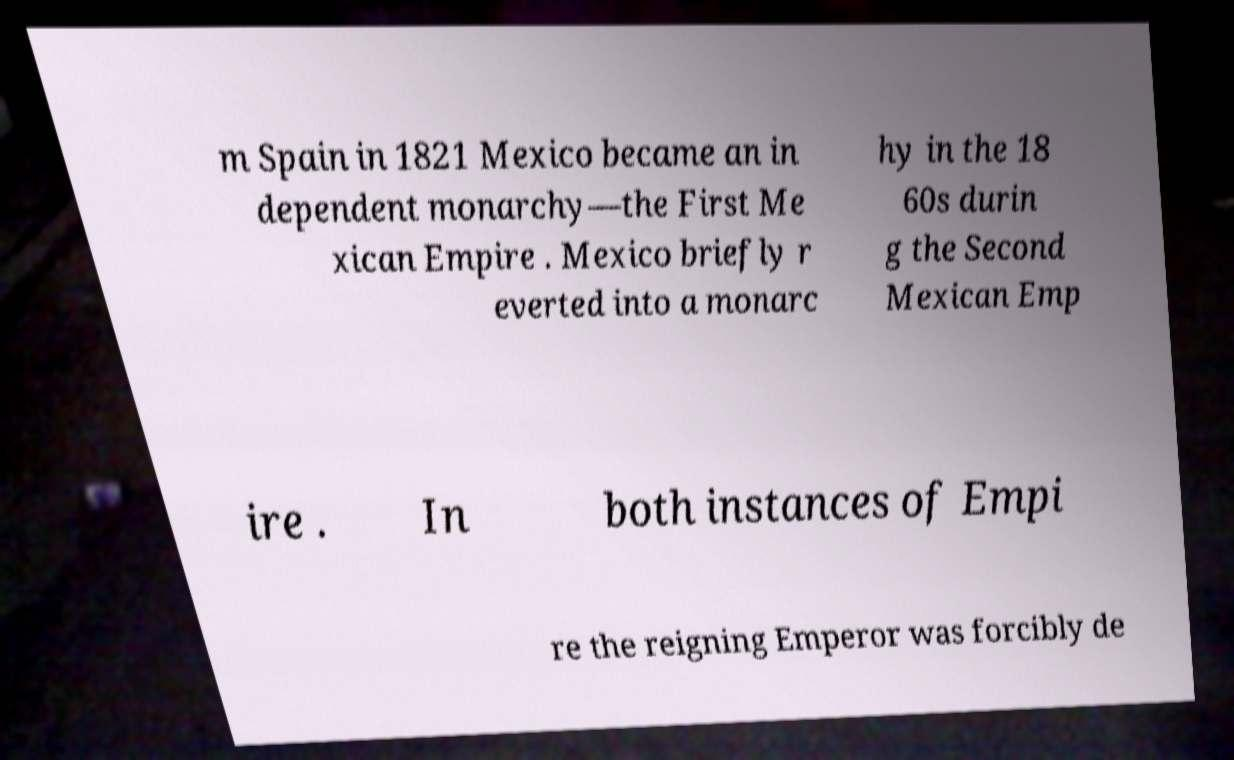Please read and relay the text visible in this image. What does it say? m Spain in 1821 Mexico became an in dependent monarchy—the First Me xican Empire . Mexico briefly r everted into a monarc hy in the 18 60s durin g the Second Mexican Emp ire . In both instances of Empi re the reigning Emperor was forcibly de 